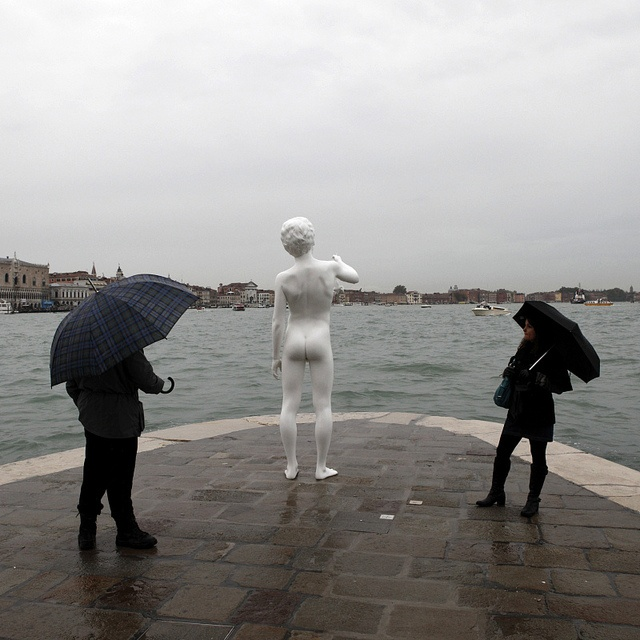Describe the objects in this image and their specific colors. I can see people in white, black, and gray tones, umbrella in white, black, gray, and darkblue tones, people in white, black, gray, darkgray, and maroon tones, umbrella in white, black, gray, lightgray, and darkgray tones, and handbag in white, black, purple, gray, and darkblue tones in this image. 